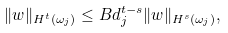<formula> <loc_0><loc_0><loc_500><loc_500>\| w \| _ { H ^ { t } ( \omega _ { j } ) } \leq B d _ { j } ^ { t - s } \| w \| _ { H ^ { s } ( \omega _ { j } ) } ,</formula> 